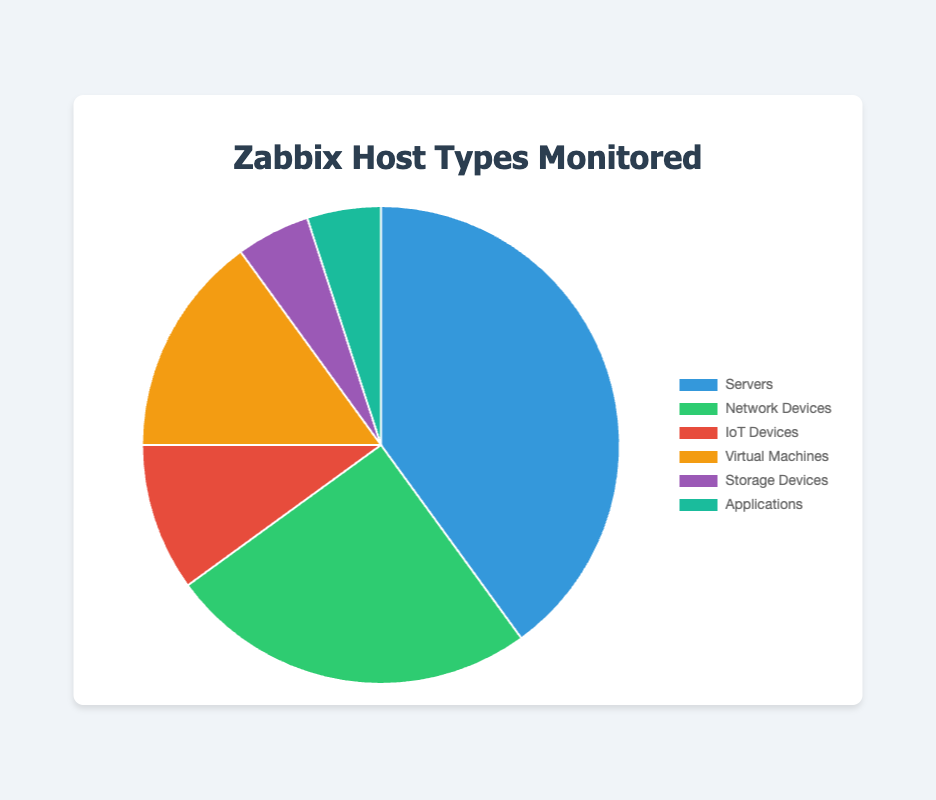Which host type has the highest percentage of monitored hosts? From the figure, the type with the largest segment of the pie chart is "Servers". It's visually the largest and represents 40% of the total monitored hosts.
Answer: Servers What's the combined percentage of IoT Devices and Applications? The figure shows that IoT Devices account for 10% and Applications for 5%. Adding these together, 10% + 5% = 15%.
Answer: 15% How does the percentage of Network Devices compare to Virtual Machines? The percentages for Network Devices and Virtual Machines are 25% and 15%, respectively. To find the difference, calculate 25% - 15% = 10%. Network Devices have a 10% higher percentage than Virtual Machines.
Answer: Network Devices are 10% higher Which type of monitored host has the smallest percentage and what is it? From the figure, both Storage Devices and Applications each have the smallest percentages, both at 5%.
Answer: Storage Devices and Applications What is the difference between the percentage of Servers and the combined percentage of IoT Devices and Storage Devices? The percentage for Servers is 40%. The combined percentage for IoT Devices (10%) and Storage Devices (5%) is 10% + 5% = 15%. The difference is 40% - 15% = 25%.
Answer: 25% What is the color representing Virtual Machines in the pie chart? In the pie chart, Virtual Machines are represented by the color yellow, as the segment labeled 'Virtual Machines' shows a yellow section.
Answer: Yellow Which monitored host types combined make up over 50% of the total? The types are Servers (40%) and Network Devices (25%). Adding these gives 40% + 25% = 65%, which is over 50%.
Answer: Servers and Network Devices How does the percentage of Network Devices compare to the combined percentage of Storage Devices and Applications? The percentage for Network Devices is 25%. The combined percentage for Storage Devices (5%) and Applications (5%) is 5% + 5% = 10%. So Network Devices have 25% - 10% = 15% higher percentage than the combined percentage of Storage Devices and Applications.
Answer: Network Devices are 15% higher Arrange the host types in ascending order based on their percentage. From the pie chart, the percentages are: Storage Devices (5%), Applications (5%), IoT Devices (10%), Virtual Machines (15%), Network Devices (25%), Servers (40%). Sorting in ascending order: Storage Devices, Applications, IoT Devices, Virtual Machines, Network Devices, Servers.
Answer: Storage Devices, Applications, IoT Devices, Virtual Machines, Network Devices, Servers 